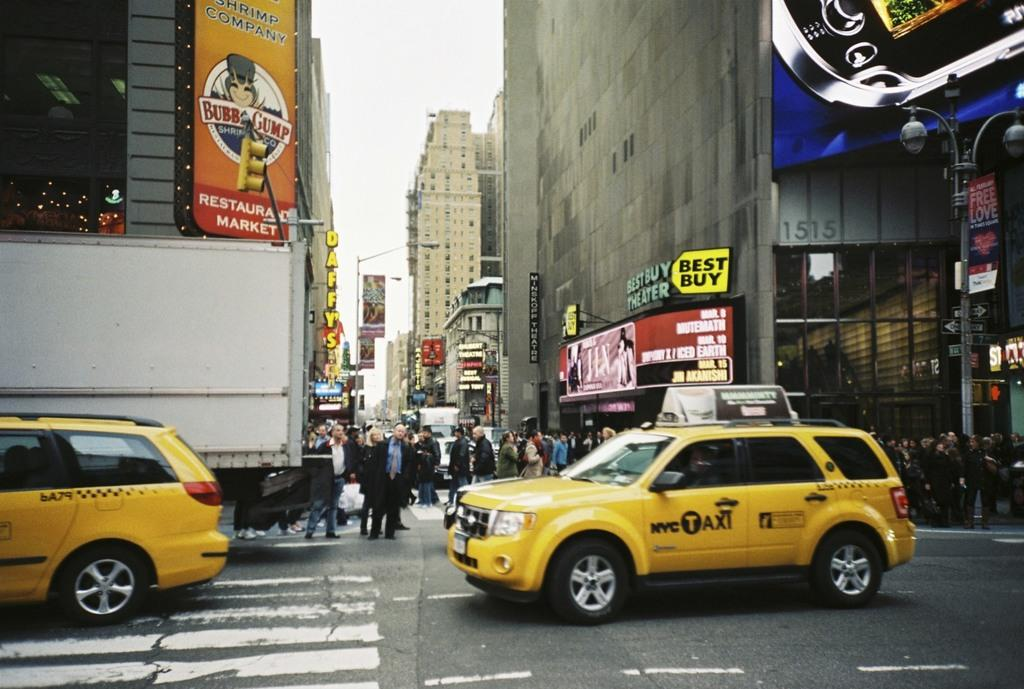<image>
Write a terse but informative summary of the picture. a car that has the word taxi on the side of it 